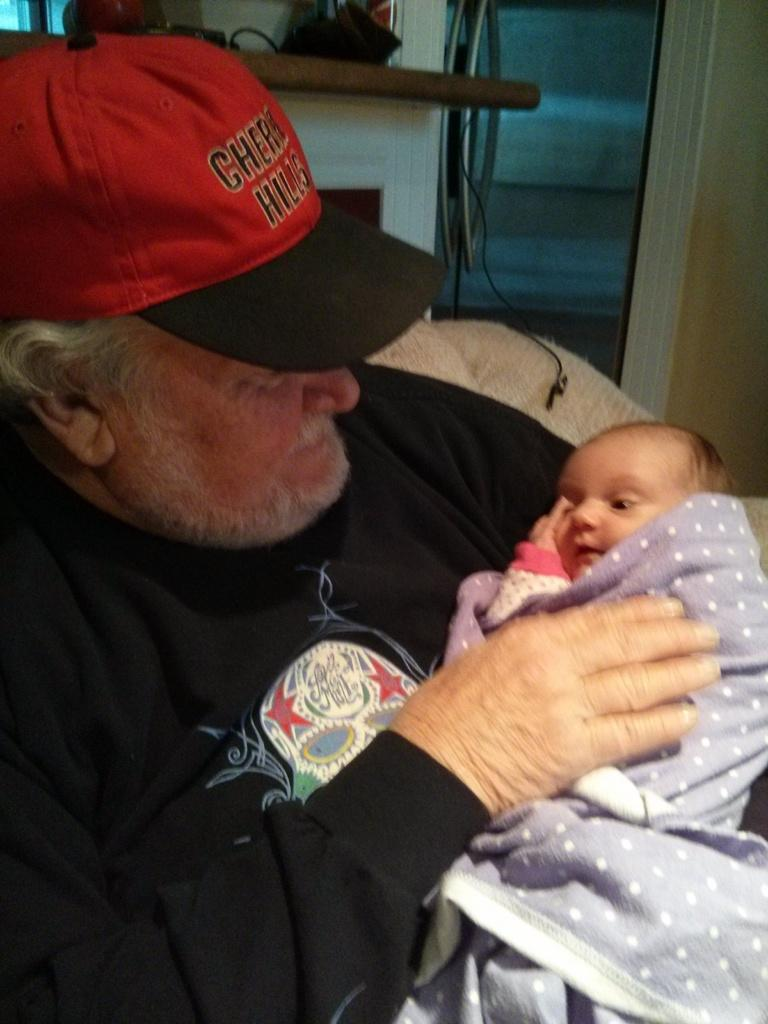<image>
Present a compact description of the photo's key features. Cherry Hills is embroidered onto this gentleman's hat. 